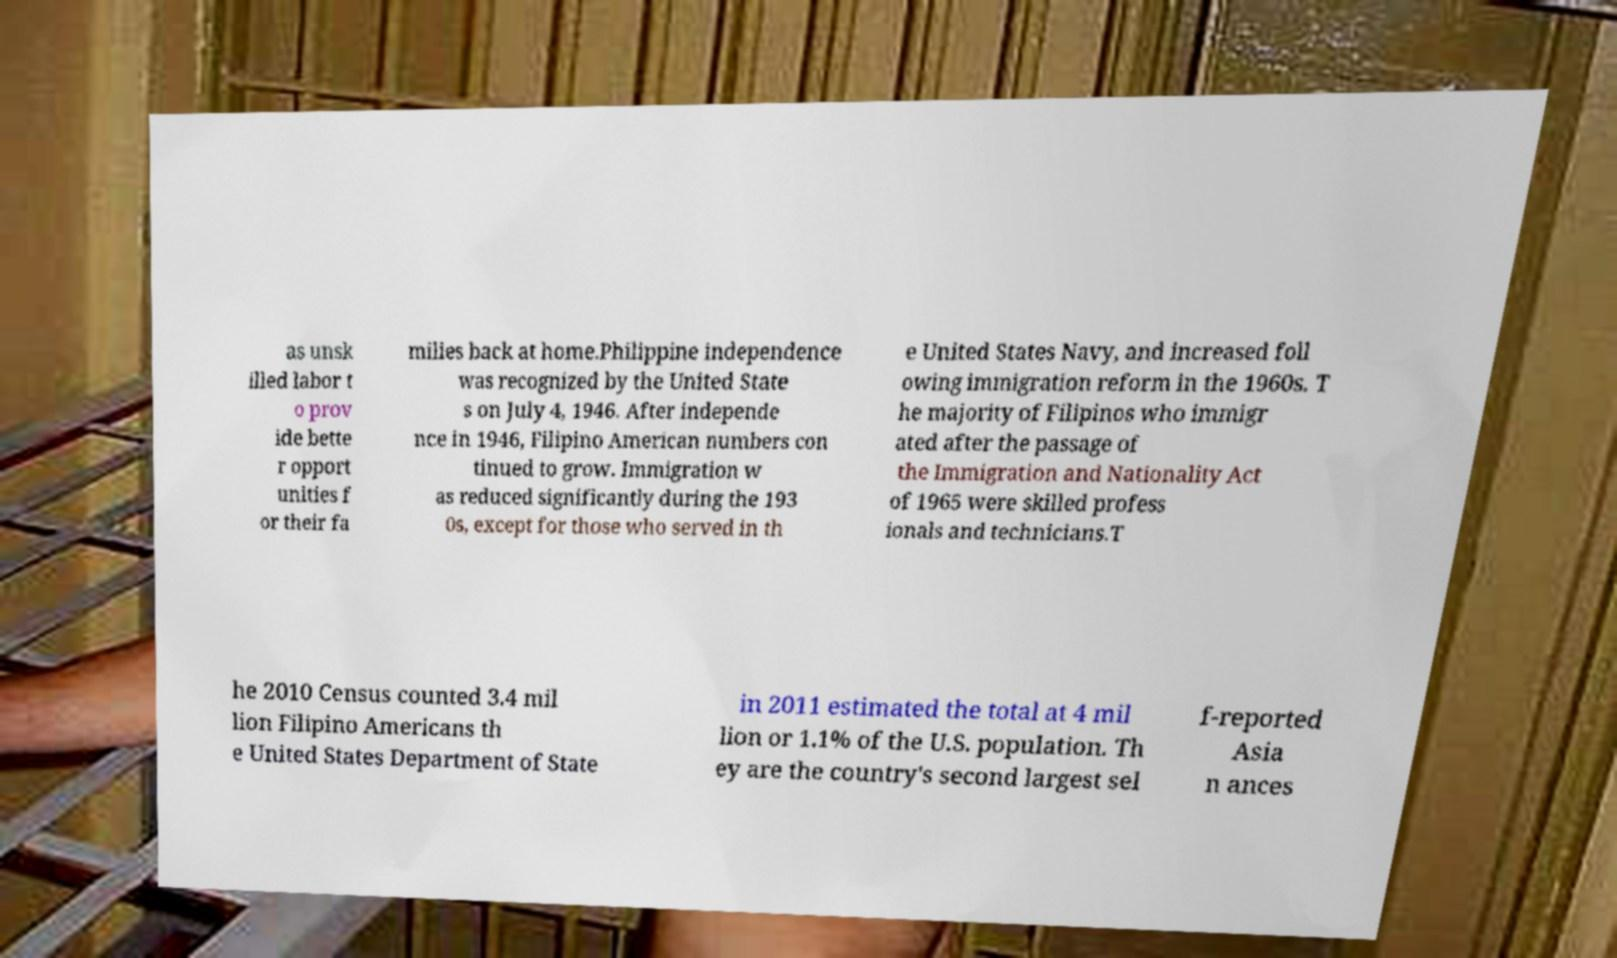Could you assist in decoding the text presented in this image and type it out clearly? as unsk illed labor t o prov ide bette r opport unities f or their fa milies back at home.Philippine independence was recognized by the United State s on July 4, 1946. After independe nce in 1946, Filipino American numbers con tinued to grow. Immigration w as reduced significantly during the 193 0s, except for those who served in th e United States Navy, and increased foll owing immigration reform in the 1960s. T he majority of Filipinos who immigr ated after the passage of the Immigration and Nationality Act of 1965 were skilled profess ionals and technicians.T he 2010 Census counted 3.4 mil lion Filipino Americans th e United States Department of State in 2011 estimated the total at 4 mil lion or 1.1% of the U.S. population. Th ey are the country's second largest sel f-reported Asia n ances 